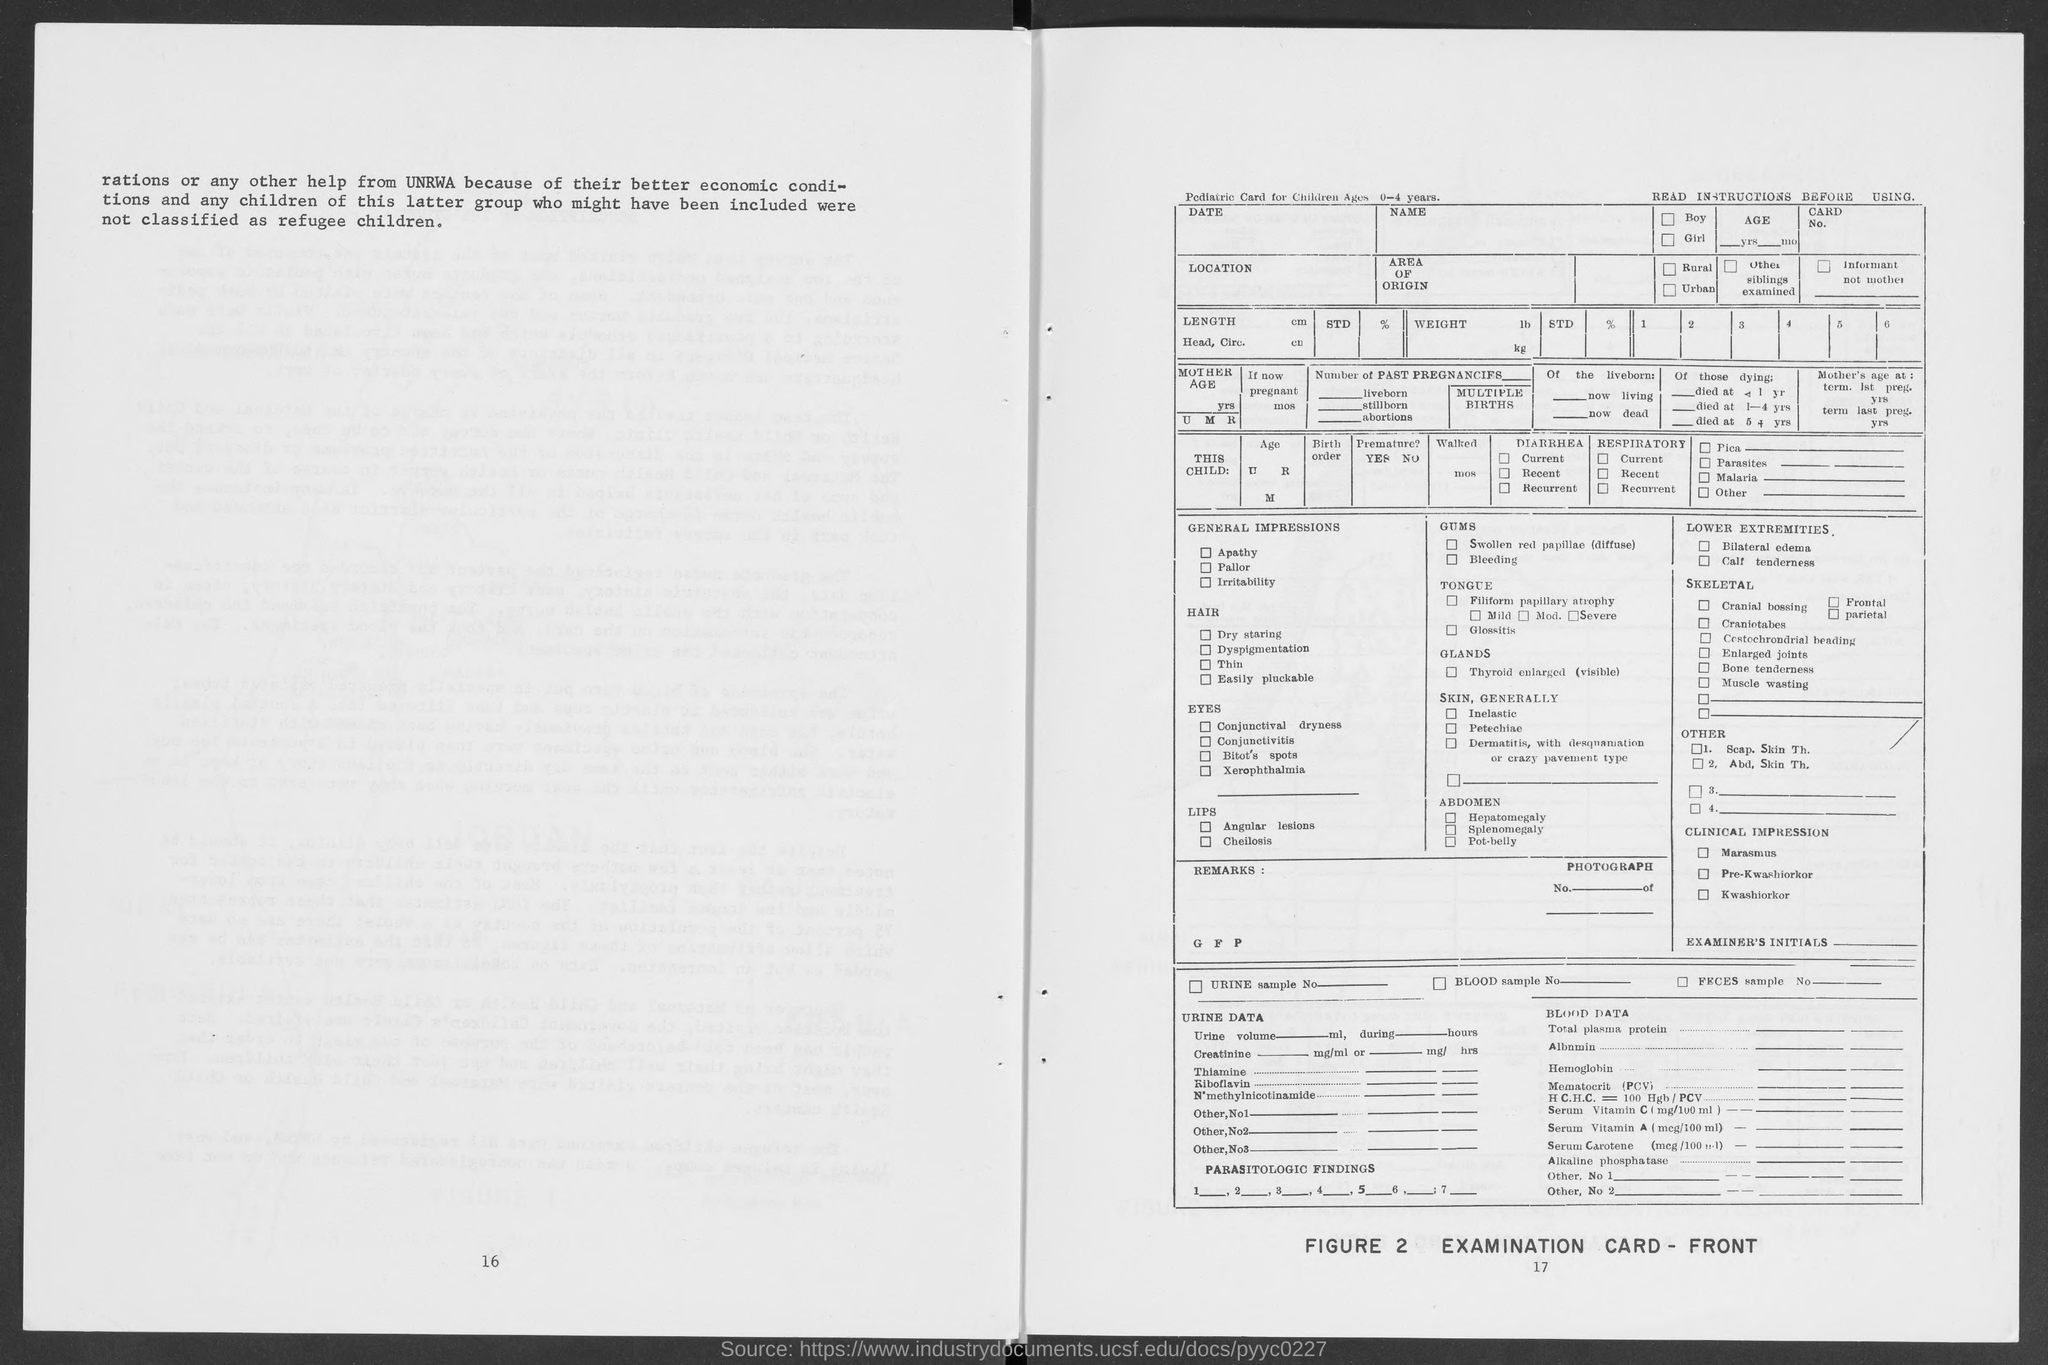Give some essential details in this illustration. Figure 2 is titled 'Examination Card Front,' which depicts a detailed and informative representation of a medical examination card, showcasing various important information and medical details. 